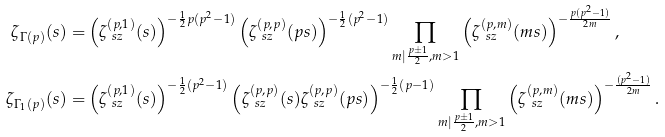Convert formula to latex. <formula><loc_0><loc_0><loc_500><loc_500>\zeta _ { \Gamma ( p ) } ( s ) = & \left ( \zeta _ { \ s z } ^ { ( p , 1 ) } ( s ) \right ) ^ { - \frac { 1 } { 2 } p ( p ^ { 2 } - 1 ) } \left ( \zeta _ { \ s z } ^ { ( p , p ) } ( p s ) \right ) ^ { - \frac { 1 } { 2 } ( p ^ { 2 } - 1 ) } \prod _ { m | \frac { p \pm 1 } { 2 } , m > 1 } \left ( \zeta _ { \ s z } ^ { ( p , m ) } ( m s ) \right ) ^ { - \frac { p ( p ^ { 2 } - 1 ) } { 2 m } } , \\ \zeta _ { \Gamma _ { 1 } ( p ) } ( s ) = & \left ( \zeta _ { \ s z } ^ { ( p , 1 ) } ( s ) \right ) ^ { - \frac { 1 } { 2 } ( p ^ { 2 } - 1 ) } \left ( \zeta _ { \ s z } ^ { ( p , p ) } ( s ) \zeta _ { \ s z } ^ { ( p , p ) } ( p s ) \right ) ^ { - \frac { 1 } { 2 } ( p - 1 ) } \prod _ { m | \frac { p \pm 1 } { 2 } , m > 1 } \left ( \zeta _ { \ s z } ^ { ( p , m ) } ( m s ) \right ) ^ { - \frac { ( p ^ { 2 } - 1 ) } { 2 m } } .</formula> 